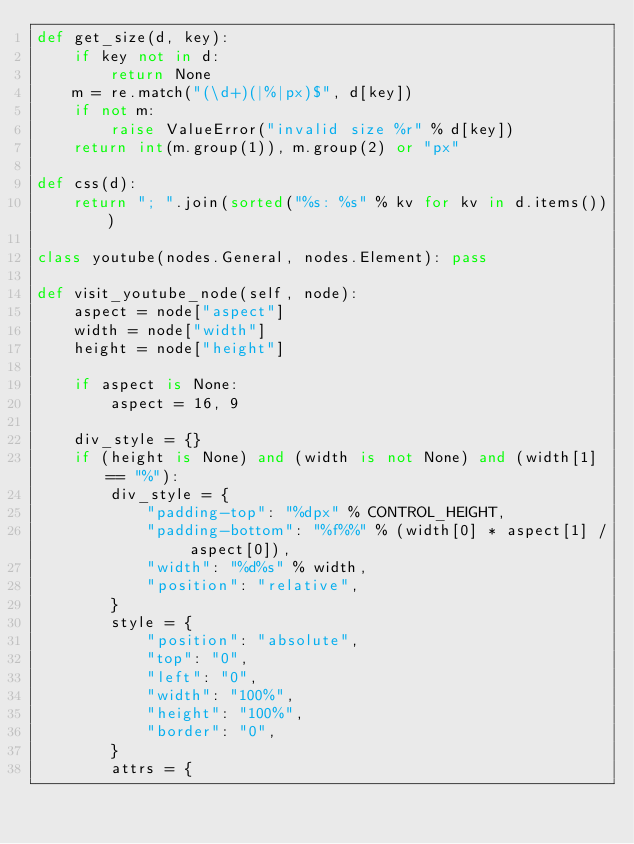<code> <loc_0><loc_0><loc_500><loc_500><_Python_>def get_size(d, key):
    if key not in d:
        return None
    m = re.match("(\d+)(|%|px)$", d[key])
    if not m:
        raise ValueError("invalid size %r" % d[key])
    return int(m.group(1)), m.group(2) or "px"

def css(d):
    return "; ".join(sorted("%s: %s" % kv for kv in d.items()))

class youtube(nodes.General, nodes.Element): pass

def visit_youtube_node(self, node):
    aspect = node["aspect"]
    width = node["width"]
    height = node["height"]

    if aspect is None:
        aspect = 16, 9

    div_style = {}
    if (height is None) and (width is not None) and (width[1] == "%"):
        div_style = {
            "padding-top": "%dpx" % CONTROL_HEIGHT,
            "padding-bottom": "%f%%" % (width[0] * aspect[1] / aspect[0]),
            "width": "%d%s" % width,
            "position": "relative",
        }
        style = {
            "position": "absolute",
            "top": "0",
            "left": "0",
            "width": "100%",
            "height": "100%",
            "border": "0",
        }
        attrs = {</code> 